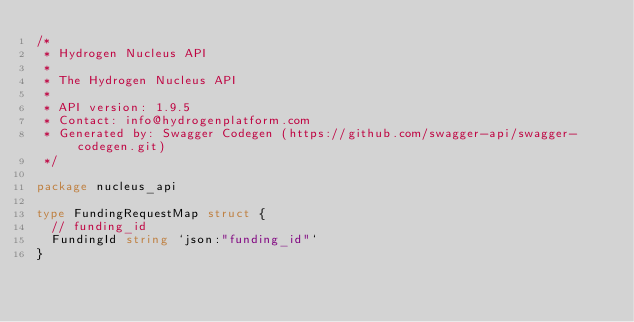<code> <loc_0><loc_0><loc_500><loc_500><_Go_>/*
 * Hydrogen Nucleus API
 *
 * The Hydrogen Nucleus API
 *
 * API version: 1.9.5
 * Contact: info@hydrogenplatform.com
 * Generated by: Swagger Codegen (https://github.com/swagger-api/swagger-codegen.git)
 */

package nucleus_api

type FundingRequestMap struct {
	// funding_id
	FundingId string `json:"funding_id"`
}
</code> 